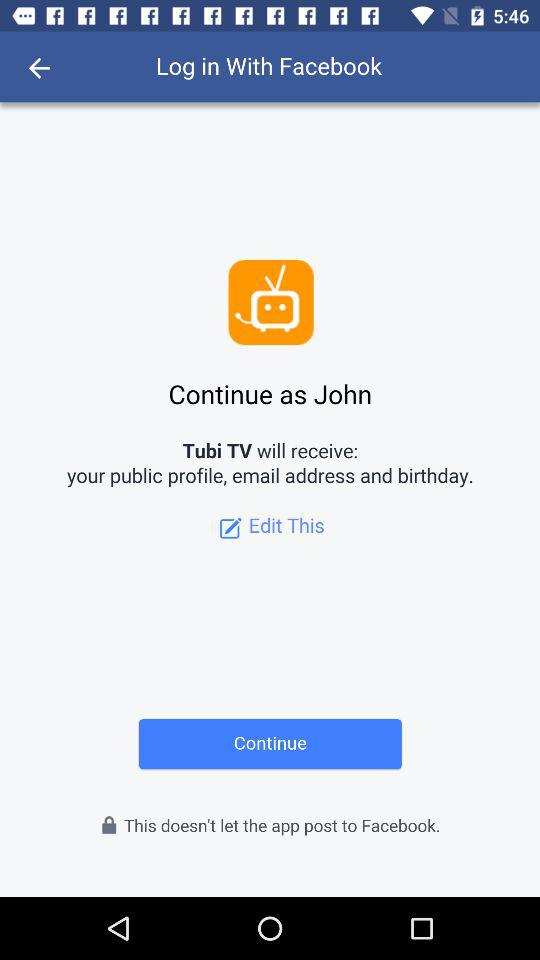What is the application through which we can log in? You can log in with "Facebook". 